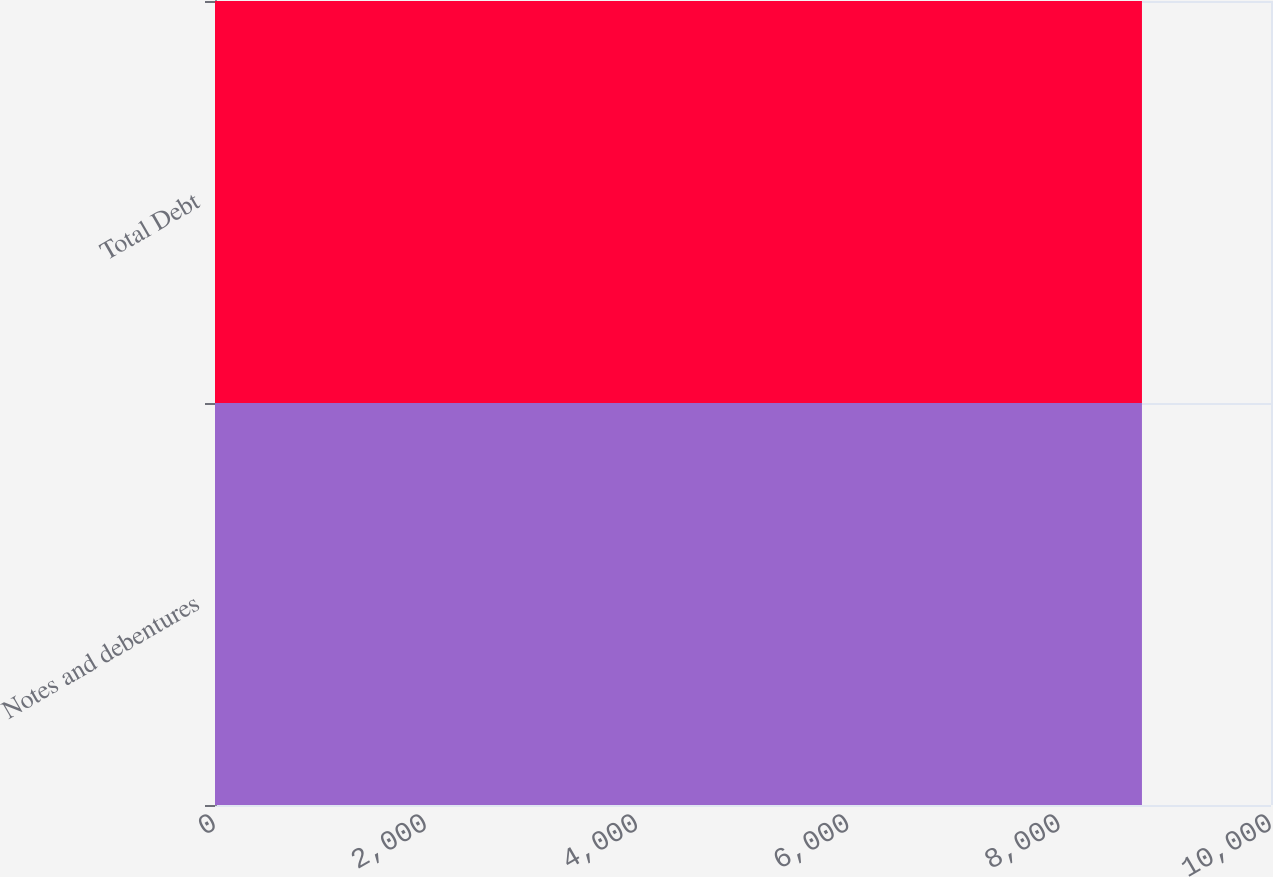<chart> <loc_0><loc_0><loc_500><loc_500><bar_chart><fcel>Notes and debentures<fcel>Total Debt<nl><fcel>8778<fcel>8778.1<nl></chart> 